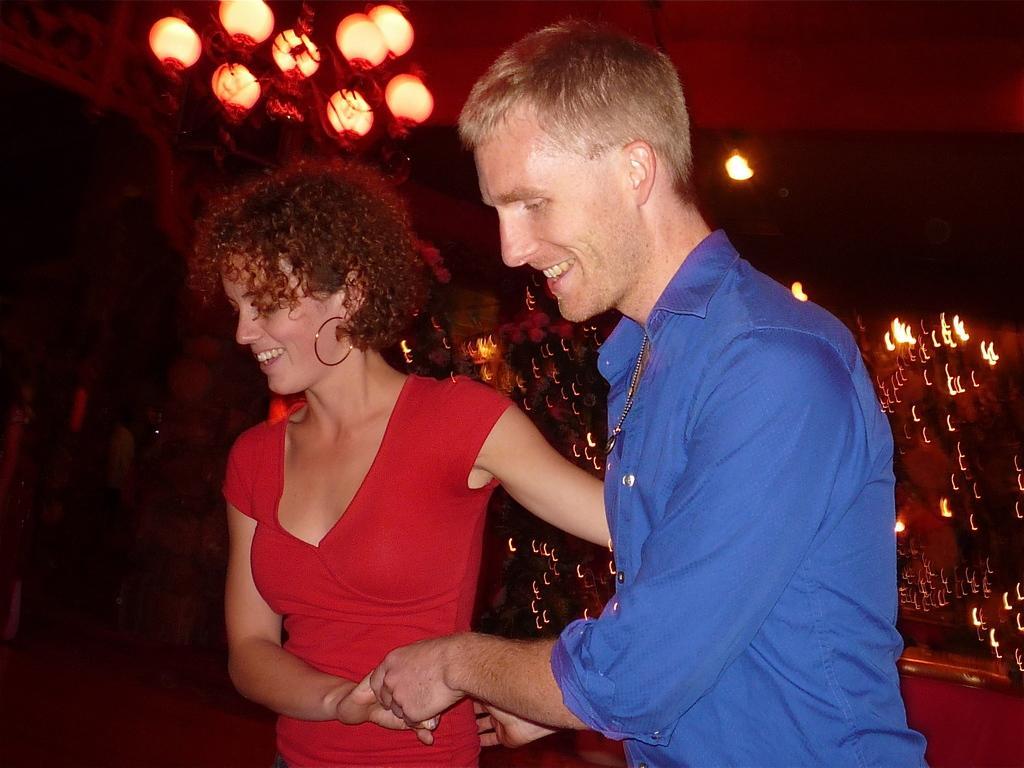Please provide a concise description of this image. In the image there are two people and they are holding their hands and behind them there are beautiful lights. 